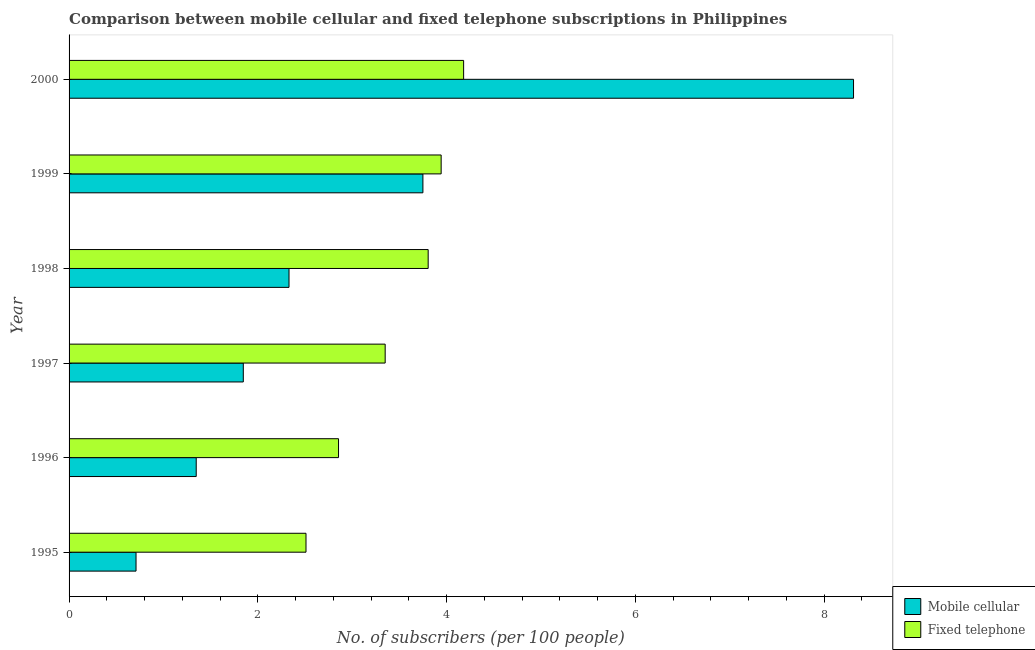How many different coloured bars are there?
Ensure brevity in your answer.  2. Are the number of bars per tick equal to the number of legend labels?
Make the answer very short. Yes. How many bars are there on the 6th tick from the bottom?
Offer a very short reply. 2. What is the label of the 4th group of bars from the top?
Your response must be concise. 1997. What is the number of mobile cellular subscribers in 1998?
Offer a terse response. 2.33. Across all years, what is the maximum number of mobile cellular subscribers?
Your response must be concise. 8.31. Across all years, what is the minimum number of mobile cellular subscribers?
Keep it short and to the point. 0.71. What is the total number of mobile cellular subscribers in the graph?
Your response must be concise. 18.29. What is the difference between the number of mobile cellular subscribers in 1998 and that in 2000?
Your answer should be very brief. -5.98. What is the difference between the number of fixed telephone subscribers in 1998 and the number of mobile cellular subscribers in 1997?
Your answer should be compact. 1.96. What is the average number of mobile cellular subscribers per year?
Provide a short and direct response. 3.05. In the year 1996, what is the difference between the number of mobile cellular subscribers and number of fixed telephone subscribers?
Provide a short and direct response. -1.51. In how many years, is the number of fixed telephone subscribers greater than 1.6 ?
Your answer should be compact. 6. Is the difference between the number of fixed telephone subscribers in 1998 and 2000 greater than the difference between the number of mobile cellular subscribers in 1998 and 2000?
Your answer should be compact. Yes. What is the difference between the highest and the second highest number of fixed telephone subscribers?
Provide a succinct answer. 0.24. What is the difference between the highest and the lowest number of mobile cellular subscribers?
Offer a very short reply. 7.6. What does the 2nd bar from the top in 2000 represents?
Provide a short and direct response. Mobile cellular. What does the 2nd bar from the bottom in 2000 represents?
Ensure brevity in your answer.  Fixed telephone. Are all the bars in the graph horizontal?
Give a very brief answer. Yes. How many years are there in the graph?
Your response must be concise. 6. Does the graph contain any zero values?
Ensure brevity in your answer.  No. Does the graph contain grids?
Your answer should be compact. No. What is the title of the graph?
Your answer should be compact. Comparison between mobile cellular and fixed telephone subscriptions in Philippines. Does "Male labor force" appear as one of the legend labels in the graph?
Make the answer very short. No. What is the label or title of the X-axis?
Offer a very short reply. No. of subscribers (per 100 people). What is the No. of subscribers (per 100 people) of Mobile cellular in 1995?
Provide a succinct answer. 0.71. What is the No. of subscribers (per 100 people) in Fixed telephone in 1995?
Your answer should be very brief. 2.51. What is the No. of subscribers (per 100 people) of Mobile cellular in 1996?
Provide a short and direct response. 1.35. What is the No. of subscribers (per 100 people) of Fixed telephone in 1996?
Ensure brevity in your answer.  2.86. What is the No. of subscribers (per 100 people) of Mobile cellular in 1997?
Your answer should be compact. 1.85. What is the No. of subscribers (per 100 people) in Fixed telephone in 1997?
Your answer should be very brief. 3.35. What is the No. of subscribers (per 100 people) of Mobile cellular in 1998?
Provide a succinct answer. 2.33. What is the No. of subscribers (per 100 people) of Fixed telephone in 1998?
Offer a terse response. 3.8. What is the No. of subscribers (per 100 people) of Mobile cellular in 1999?
Make the answer very short. 3.75. What is the No. of subscribers (per 100 people) of Fixed telephone in 1999?
Ensure brevity in your answer.  3.94. What is the No. of subscribers (per 100 people) in Mobile cellular in 2000?
Make the answer very short. 8.31. What is the No. of subscribers (per 100 people) in Fixed telephone in 2000?
Offer a very short reply. 4.18. Across all years, what is the maximum No. of subscribers (per 100 people) of Mobile cellular?
Provide a short and direct response. 8.31. Across all years, what is the maximum No. of subscribers (per 100 people) in Fixed telephone?
Offer a terse response. 4.18. Across all years, what is the minimum No. of subscribers (per 100 people) in Mobile cellular?
Provide a succinct answer. 0.71. Across all years, what is the minimum No. of subscribers (per 100 people) of Fixed telephone?
Your response must be concise. 2.51. What is the total No. of subscribers (per 100 people) of Mobile cellular in the graph?
Ensure brevity in your answer.  18.29. What is the total No. of subscribers (per 100 people) of Fixed telephone in the graph?
Your answer should be compact. 20.64. What is the difference between the No. of subscribers (per 100 people) of Mobile cellular in 1995 and that in 1996?
Provide a succinct answer. -0.64. What is the difference between the No. of subscribers (per 100 people) of Fixed telephone in 1995 and that in 1996?
Your answer should be compact. -0.34. What is the difference between the No. of subscribers (per 100 people) of Mobile cellular in 1995 and that in 1997?
Provide a short and direct response. -1.14. What is the difference between the No. of subscribers (per 100 people) of Fixed telephone in 1995 and that in 1997?
Provide a short and direct response. -0.84. What is the difference between the No. of subscribers (per 100 people) of Mobile cellular in 1995 and that in 1998?
Your response must be concise. -1.62. What is the difference between the No. of subscribers (per 100 people) in Fixed telephone in 1995 and that in 1998?
Ensure brevity in your answer.  -1.29. What is the difference between the No. of subscribers (per 100 people) of Mobile cellular in 1995 and that in 1999?
Ensure brevity in your answer.  -3.04. What is the difference between the No. of subscribers (per 100 people) of Fixed telephone in 1995 and that in 1999?
Your answer should be very brief. -1.43. What is the difference between the No. of subscribers (per 100 people) of Mobile cellular in 1995 and that in 2000?
Provide a succinct answer. -7.6. What is the difference between the No. of subscribers (per 100 people) of Fixed telephone in 1995 and that in 2000?
Make the answer very short. -1.67. What is the difference between the No. of subscribers (per 100 people) in Mobile cellular in 1996 and that in 1997?
Your answer should be very brief. -0.5. What is the difference between the No. of subscribers (per 100 people) in Fixed telephone in 1996 and that in 1997?
Ensure brevity in your answer.  -0.49. What is the difference between the No. of subscribers (per 100 people) of Mobile cellular in 1996 and that in 1998?
Provide a succinct answer. -0.98. What is the difference between the No. of subscribers (per 100 people) of Fixed telephone in 1996 and that in 1998?
Keep it short and to the point. -0.95. What is the difference between the No. of subscribers (per 100 people) in Mobile cellular in 1996 and that in 1999?
Give a very brief answer. -2.4. What is the difference between the No. of subscribers (per 100 people) of Fixed telephone in 1996 and that in 1999?
Give a very brief answer. -1.09. What is the difference between the No. of subscribers (per 100 people) in Mobile cellular in 1996 and that in 2000?
Provide a succinct answer. -6.96. What is the difference between the No. of subscribers (per 100 people) of Fixed telephone in 1996 and that in 2000?
Make the answer very short. -1.33. What is the difference between the No. of subscribers (per 100 people) in Mobile cellular in 1997 and that in 1998?
Offer a very short reply. -0.48. What is the difference between the No. of subscribers (per 100 people) of Fixed telephone in 1997 and that in 1998?
Offer a terse response. -0.46. What is the difference between the No. of subscribers (per 100 people) of Mobile cellular in 1997 and that in 1999?
Give a very brief answer. -1.9. What is the difference between the No. of subscribers (per 100 people) of Fixed telephone in 1997 and that in 1999?
Your answer should be compact. -0.59. What is the difference between the No. of subscribers (per 100 people) of Mobile cellular in 1997 and that in 2000?
Ensure brevity in your answer.  -6.47. What is the difference between the No. of subscribers (per 100 people) in Fixed telephone in 1997 and that in 2000?
Your answer should be very brief. -0.83. What is the difference between the No. of subscribers (per 100 people) of Mobile cellular in 1998 and that in 1999?
Your answer should be compact. -1.42. What is the difference between the No. of subscribers (per 100 people) of Fixed telephone in 1998 and that in 1999?
Give a very brief answer. -0.14. What is the difference between the No. of subscribers (per 100 people) of Mobile cellular in 1998 and that in 2000?
Keep it short and to the point. -5.98. What is the difference between the No. of subscribers (per 100 people) of Fixed telephone in 1998 and that in 2000?
Your answer should be compact. -0.38. What is the difference between the No. of subscribers (per 100 people) of Mobile cellular in 1999 and that in 2000?
Make the answer very short. -4.56. What is the difference between the No. of subscribers (per 100 people) of Fixed telephone in 1999 and that in 2000?
Make the answer very short. -0.24. What is the difference between the No. of subscribers (per 100 people) of Mobile cellular in 1995 and the No. of subscribers (per 100 people) of Fixed telephone in 1996?
Provide a succinct answer. -2.15. What is the difference between the No. of subscribers (per 100 people) in Mobile cellular in 1995 and the No. of subscribers (per 100 people) in Fixed telephone in 1997?
Your answer should be compact. -2.64. What is the difference between the No. of subscribers (per 100 people) in Mobile cellular in 1995 and the No. of subscribers (per 100 people) in Fixed telephone in 1998?
Your response must be concise. -3.1. What is the difference between the No. of subscribers (per 100 people) of Mobile cellular in 1995 and the No. of subscribers (per 100 people) of Fixed telephone in 1999?
Offer a terse response. -3.23. What is the difference between the No. of subscribers (per 100 people) of Mobile cellular in 1995 and the No. of subscribers (per 100 people) of Fixed telephone in 2000?
Your answer should be compact. -3.47. What is the difference between the No. of subscribers (per 100 people) of Mobile cellular in 1996 and the No. of subscribers (per 100 people) of Fixed telephone in 1997?
Your response must be concise. -2. What is the difference between the No. of subscribers (per 100 people) of Mobile cellular in 1996 and the No. of subscribers (per 100 people) of Fixed telephone in 1998?
Offer a very short reply. -2.46. What is the difference between the No. of subscribers (per 100 people) of Mobile cellular in 1996 and the No. of subscribers (per 100 people) of Fixed telephone in 1999?
Offer a terse response. -2.6. What is the difference between the No. of subscribers (per 100 people) in Mobile cellular in 1996 and the No. of subscribers (per 100 people) in Fixed telephone in 2000?
Offer a terse response. -2.83. What is the difference between the No. of subscribers (per 100 people) in Mobile cellular in 1997 and the No. of subscribers (per 100 people) in Fixed telephone in 1998?
Your answer should be compact. -1.96. What is the difference between the No. of subscribers (per 100 people) of Mobile cellular in 1997 and the No. of subscribers (per 100 people) of Fixed telephone in 1999?
Give a very brief answer. -2.1. What is the difference between the No. of subscribers (per 100 people) of Mobile cellular in 1997 and the No. of subscribers (per 100 people) of Fixed telephone in 2000?
Provide a succinct answer. -2.33. What is the difference between the No. of subscribers (per 100 people) of Mobile cellular in 1998 and the No. of subscribers (per 100 people) of Fixed telephone in 1999?
Offer a very short reply. -1.61. What is the difference between the No. of subscribers (per 100 people) in Mobile cellular in 1998 and the No. of subscribers (per 100 people) in Fixed telephone in 2000?
Provide a succinct answer. -1.85. What is the difference between the No. of subscribers (per 100 people) in Mobile cellular in 1999 and the No. of subscribers (per 100 people) in Fixed telephone in 2000?
Your answer should be very brief. -0.43. What is the average No. of subscribers (per 100 people) in Mobile cellular per year?
Provide a succinct answer. 3.05. What is the average No. of subscribers (per 100 people) in Fixed telephone per year?
Provide a succinct answer. 3.44. In the year 1995, what is the difference between the No. of subscribers (per 100 people) in Mobile cellular and No. of subscribers (per 100 people) in Fixed telephone?
Your response must be concise. -1.8. In the year 1996, what is the difference between the No. of subscribers (per 100 people) of Mobile cellular and No. of subscribers (per 100 people) of Fixed telephone?
Provide a succinct answer. -1.51. In the year 1997, what is the difference between the No. of subscribers (per 100 people) in Mobile cellular and No. of subscribers (per 100 people) in Fixed telephone?
Provide a succinct answer. -1.5. In the year 1998, what is the difference between the No. of subscribers (per 100 people) in Mobile cellular and No. of subscribers (per 100 people) in Fixed telephone?
Provide a short and direct response. -1.47. In the year 1999, what is the difference between the No. of subscribers (per 100 people) in Mobile cellular and No. of subscribers (per 100 people) in Fixed telephone?
Offer a terse response. -0.19. In the year 2000, what is the difference between the No. of subscribers (per 100 people) of Mobile cellular and No. of subscribers (per 100 people) of Fixed telephone?
Offer a terse response. 4.13. What is the ratio of the No. of subscribers (per 100 people) in Mobile cellular in 1995 to that in 1996?
Your answer should be very brief. 0.53. What is the ratio of the No. of subscribers (per 100 people) of Fixed telephone in 1995 to that in 1996?
Provide a short and direct response. 0.88. What is the ratio of the No. of subscribers (per 100 people) of Mobile cellular in 1995 to that in 1997?
Keep it short and to the point. 0.38. What is the ratio of the No. of subscribers (per 100 people) in Fixed telephone in 1995 to that in 1997?
Give a very brief answer. 0.75. What is the ratio of the No. of subscribers (per 100 people) in Mobile cellular in 1995 to that in 1998?
Give a very brief answer. 0.3. What is the ratio of the No. of subscribers (per 100 people) of Fixed telephone in 1995 to that in 1998?
Provide a short and direct response. 0.66. What is the ratio of the No. of subscribers (per 100 people) of Mobile cellular in 1995 to that in 1999?
Give a very brief answer. 0.19. What is the ratio of the No. of subscribers (per 100 people) in Fixed telephone in 1995 to that in 1999?
Provide a short and direct response. 0.64. What is the ratio of the No. of subscribers (per 100 people) in Mobile cellular in 1995 to that in 2000?
Make the answer very short. 0.09. What is the ratio of the No. of subscribers (per 100 people) of Fixed telephone in 1995 to that in 2000?
Make the answer very short. 0.6. What is the ratio of the No. of subscribers (per 100 people) in Mobile cellular in 1996 to that in 1997?
Your answer should be compact. 0.73. What is the ratio of the No. of subscribers (per 100 people) in Fixed telephone in 1996 to that in 1997?
Ensure brevity in your answer.  0.85. What is the ratio of the No. of subscribers (per 100 people) in Mobile cellular in 1996 to that in 1998?
Ensure brevity in your answer.  0.58. What is the ratio of the No. of subscribers (per 100 people) of Fixed telephone in 1996 to that in 1998?
Provide a short and direct response. 0.75. What is the ratio of the No. of subscribers (per 100 people) of Mobile cellular in 1996 to that in 1999?
Keep it short and to the point. 0.36. What is the ratio of the No. of subscribers (per 100 people) of Fixed telephone in 1996 to that in 1999?
Make the answer very short. 0.72. What is the ratio of the No. of subscribers (per 100 people) in Mobile cellular in 1996 to that in 2000?
Your answer should be very brief. 0.16. What is the ratio of the No. of subscribers (per 100 people) of Fixed telephone in 1996 to that in 2000?
Your answer should be very brief. 0.68. What is the ratio of the No. of subscribers (per 100 people) in Mobile cellular in 1997 to that in 1998?
Keep it short and to the point. 0.79. What is the ratio of the No. of subscribers (per 100 people) of Fixed telephone in 1997 to that in 1998?
Give a very brief answer. 0.88. What is the ratio of the No. of subscribers (per 100 people) of Mobile cellular in 1997 to that in 1999?
Provide a succinct answer. 0.49. What is the ratio of the No. of subscribers (per 100 people) in Fixed telephone in 1997 to that in 1999?
Make the answer very short. 0.85. What is the ratio of the No. of subscribers (per 100 people) of Mobile cellular in 1997 to that in 2000?
Keep it short and to the point. 0.22. What is the ratio of the No. of subscribers (per 100 people) in Fixed telephone in 1997 to that in 2000?
Provide a short and direct response. 0.8. What is the ratio of the No. of subscribers (per 100 people) in Mobile cellular in 1998 to that in 1999?
Give a very brief answer. 0.62. What is the ratio of the No. of subscribers (per 100 people) in Fixed telephone in 1998 to that in 1999?
Your answer should be very brief. 0.97. What is the ratio of the No. of subscribers (per 100 people) of Mobile cellular in 1998 to that in 2000?
Your answer should be compact. 0.28. What is the ratio of the No. of subscribers (per 100 people) of Fixed telephone in 1998 to that in 2000?
Your answer should be very brief. 0.91. What is the ratio of the No. of subscribers (per 100 people) of Mobile cellular in 1999 to that in 2000?
Make the answer very short. 0.45. What is the ratio of the No. of subscribers (per 100 people) of Fixed telephone in 1999 to that in 2000?
Offer a very short reply. 0.94. What is the difference between the highest and the second highest No. of subscribers (per 100 people) in Mobile cellular?
Your answer should be very brief. 4.56. What is the difference between the highest and the second highest No. of subscribers (per 100 people) in Fixed telephone?
Keep it short and to the point. 0.24. What is the difference between the highest and the lowest No. of subscribers (per 100 people) in Mobile cellular?
Your answer should be compact. 7.6. What is the difference between the highest and the lowest No. of subscribers (per 100 people) of Fixed telephone?
Your response must be concise. 1.67. 